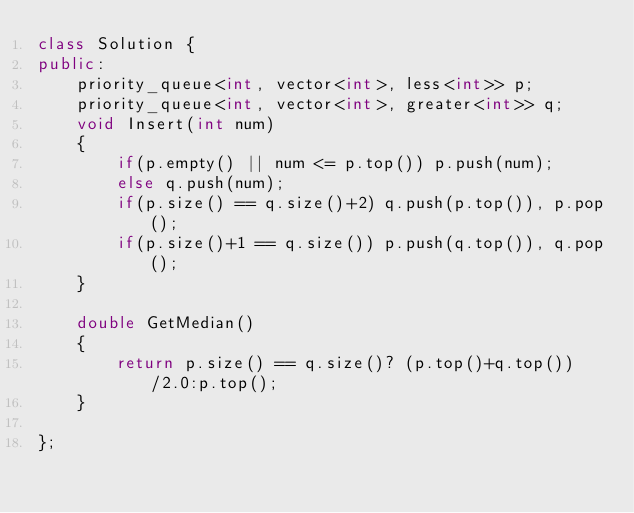Convert code to text. <code><loc_0><loc_0><loc_500><loc_500><_C++_>class Solution {
public:
    priority_queue<int, vector<int>, less<int>> p;
    priority_queue<int, vector<int>, greater<int>> q;
    void Insert(int num)
    {
        if(p.empty() || num <= p.top()) p.push(num);
        else q.push(num);
        if(p.size() == q.size()+2) q.push(p.top()), p.pop();
        if(p.size()+1 == q.size()) p.push(q.top()), q.pop();
    }

    double GetMedian()
    { 
        return p.size() == q.size()? (p.top()+q.top())/2.0:p.top();
    }

};
</code> 